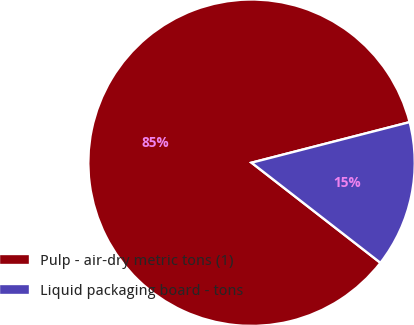Convert chart. <chart><loc_0><loc_0><loc_500><loc_500><pie_chart><fcel>Pulp - air-dry metric tons (1)<fcel>Liquid packaging board - tons<nl><fcel>85.49%<fcel>14.51%<nl></chart> 